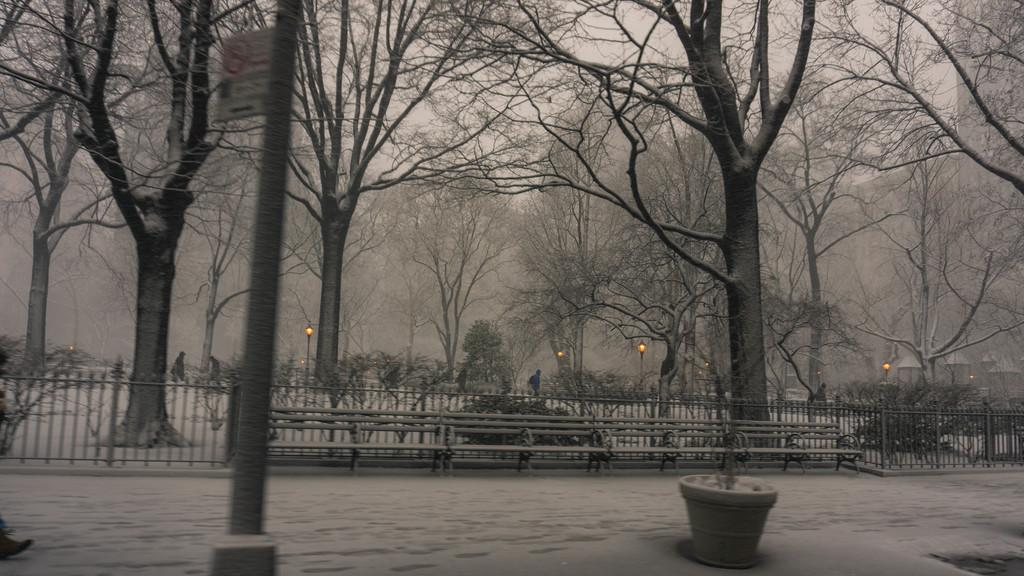Where was the image taken? The image was taken outside of the city. What can be seen in the background of the image? There is a tree, chairs, and flower pots in the background of the image. What type of quarter is visible in the image? There is no quarter present in the image. What does the tongue of the tree look like in the image? There is no tongue associated with the tree in the image, as trees do not have tongues. 